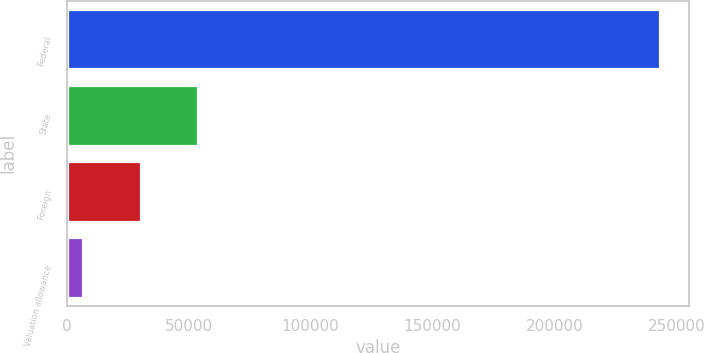<chart> <loc_0><loc_0><loc_500><loc_500><bar_chart><fcel>Federal<fcel>State<fcel>Foreign<fcel>Valuation allowance<nl><fcel>243127<fcel>54036.6<fcel>30400.3<fcel>6764<nl></chart> 